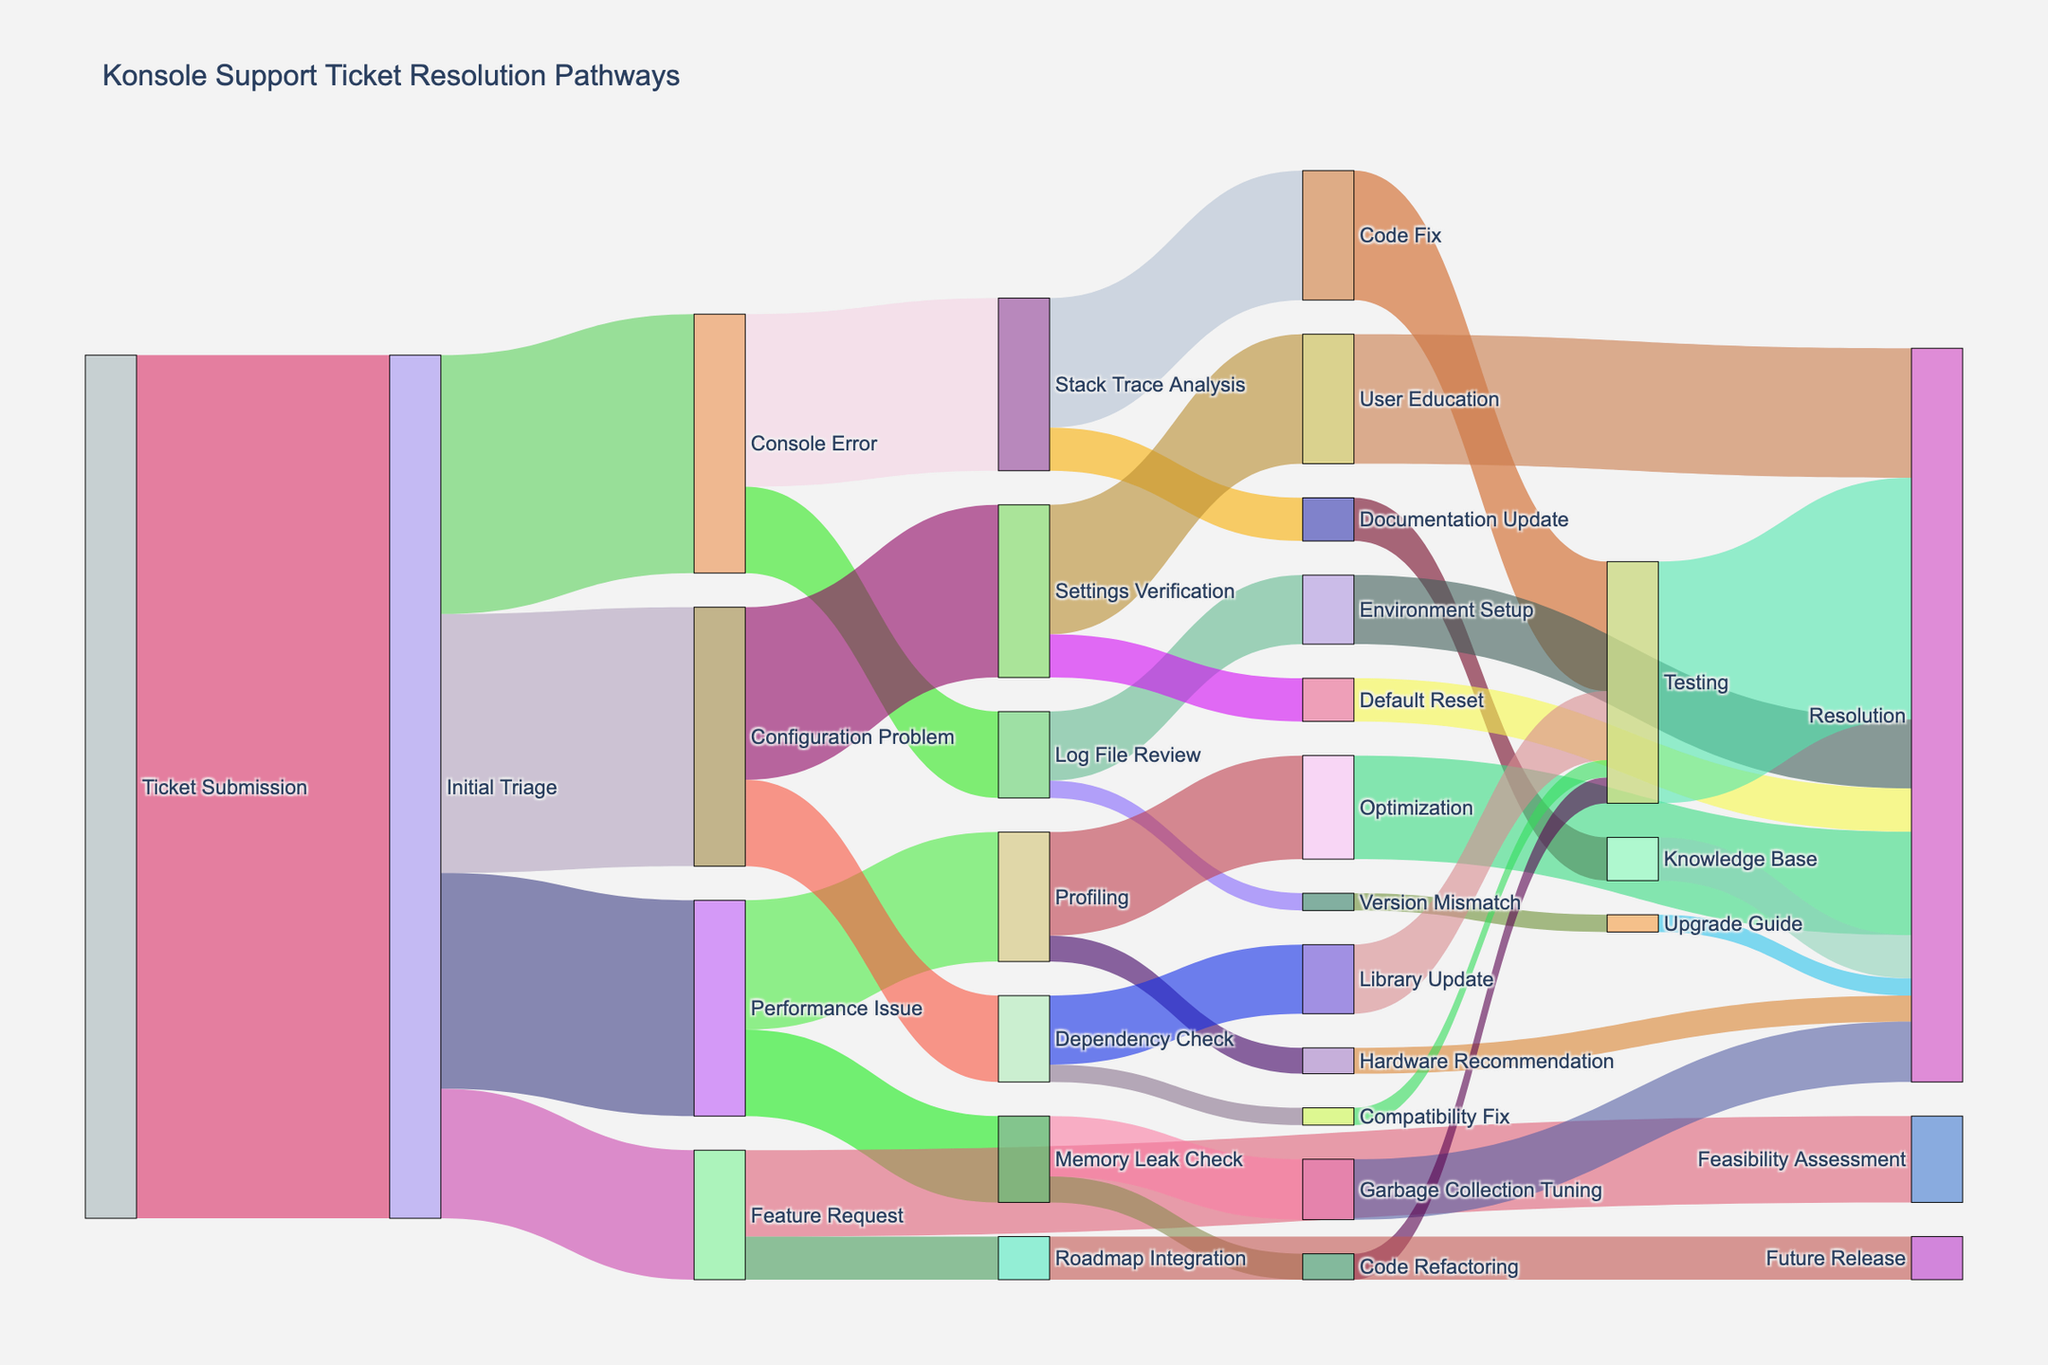how many tickets are submitted initially? You can see from the Sankey diagram that the initial flow starts from "Ticket Submission" to "Initial Triage" with a value of 100, representing the number of tickets submitted.
Answer: 100 How many tickets in total are resolved after "Testing"? The tickets reaching resolution through "Testing" can be seen in multiple flows: "Code Fix" to "Testing" (15), "Memory Leak Check" to "Testing" (3), "Library Update" to "Testing" (8), "Compatibility Fix" to "Testing" (2). Adding them up gives 15 + 3 + 8 + 2 = 28 tickets resolved after "Testing".
Answer: 28 Which issue type receives the most tickets after the Initial Triage? By comparing the values of flows from "Initial Triage", the issue types are "Console Error" (30), "Configuration Problem" (30), "Performance Issue" (25), "Feature Request" (15). The "Console Error" and "Configuration Problem" both receive the highest number of tickets at 30 each.
Answer: Console Error and Configuration Problem What is the least common resolution pathway from "Console Error"? We observe the flows from "Console Error" to "Stack Trace Analysis" (20) and "Log File Review" (10). "Log File Review" is the least common pathway.
Answer: Log File Review How many tickets are resolved directly after "User Education"? The ticket flow from "User Education" to "Resolution" is indicated with the value of 15 tickets.
Answer: 15 What is the number of tickets going through "Code Fix" before resolution? There are 15 tickets from "Stack Trace Analysis" to "Code Fix", and these directly move to "Testing" before resolution. Thus, the tickets going through "Code Fix" are 15.
Answer: 15 How does the count of tickets for "Future Release" from "Roadmap Integration" compare to the count for "Testing" from "Library Update"? "Roadmap Integration" flows to "Future Release" with 5 tickets, while "Library Update" flows to "Testing" with 8 tickets. Comparing these, the count for "Future Release" (5) is less than for "Testing" from "Library Update" (8).
Answer: Less Which step follows "Stack Trace Analysis" more frequently, "Code Fix" or "Documentation Update"? From the Sankey diagram, "Stack Trace Analysis" flows to "Code Fix" (15) and "Documentation Update" (5). Thus, "Code Fix" follows more frequently.
Answer: Code Fix Is the number of tickets for "Dependency Check" more than that of "Profiling"? "Initial Triage" flows into "Dependency Check" with 10 tickets and into "Profiling" with 15 tickets. Thus, "Profiling" has more tickets.
Answer: No What percentage of "Feature Request" tickets go through "Feasibility Assessment"? "Feature Request" flows to "Feasibility Assessment" with 10 tickets and to "Roadmap Integration" with 5 tickets. So, the percentage for "Feasibility Assessment" is (10/15) * 100 = 66.67%.
Answer: 66.67% 